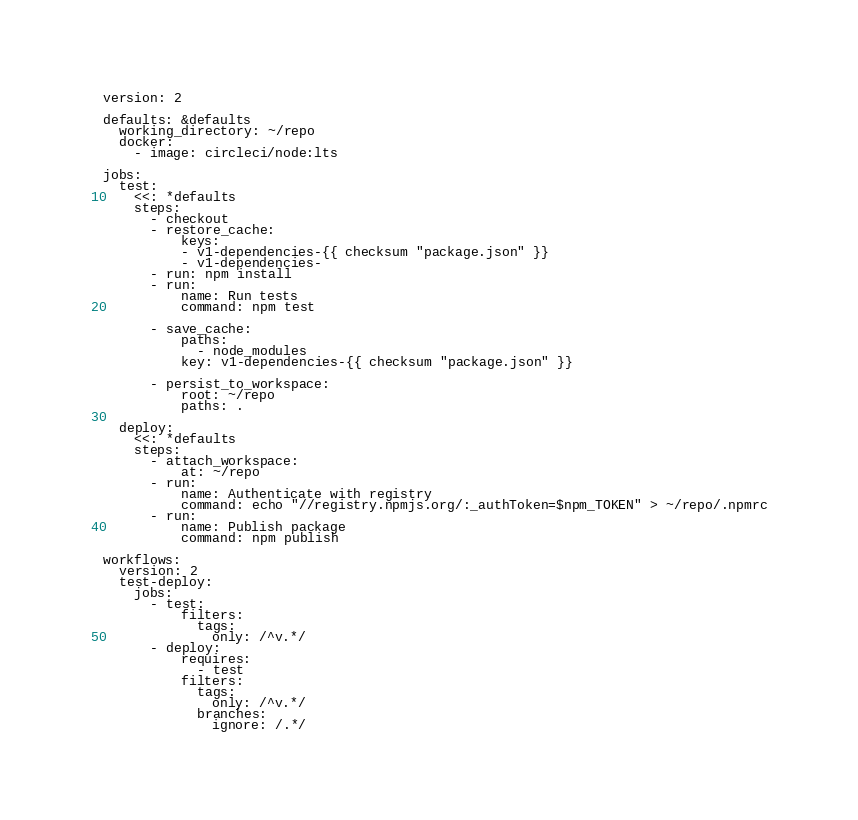<code> <loc_0><loc_0><loc_500><loc_500><_YAML_>version: 2

defaults: &defaults
  working_directory: ~/repo
  docker:
    - image: circleci/node:lts

jobs:
  test:
    <<: *defaults
    steps:
      - checkout
      - restore_cache:
          keys:
          - v1-dependencies-{{ checksum "package.json" }}
          - v1-dependencies-
      - run: npm install
      - run:
          name: Run tests
          command: npm test

      - save_cache:
          paths:
            - node_modules
          key: v1-dependencies-{{ checksum "package.json" }}

      - persist_to_workspace:
          root: ~/repo
          paths: .

  deploy:
    <<: *defaults
    steps:
      - attach_workspace:
          at: ~/repo
      - run:
          name: Authenticate with registry
          command: echo "//registry.npmjs.org/:_authToken=$npm_TOKEN" > ~/repo/.npmrc
      - run:
          name: Publish package
          command: npm publish

workflows:
  version: 2
  test-deploy:
    jobs:
      - test:
          filters:
            tags:
              only: /^v.*/
      - deploy:
          requires:
            - test
          filters:
            tags:
              only: /^v.*/
            branches:
              ignore: /.*/

</code> 